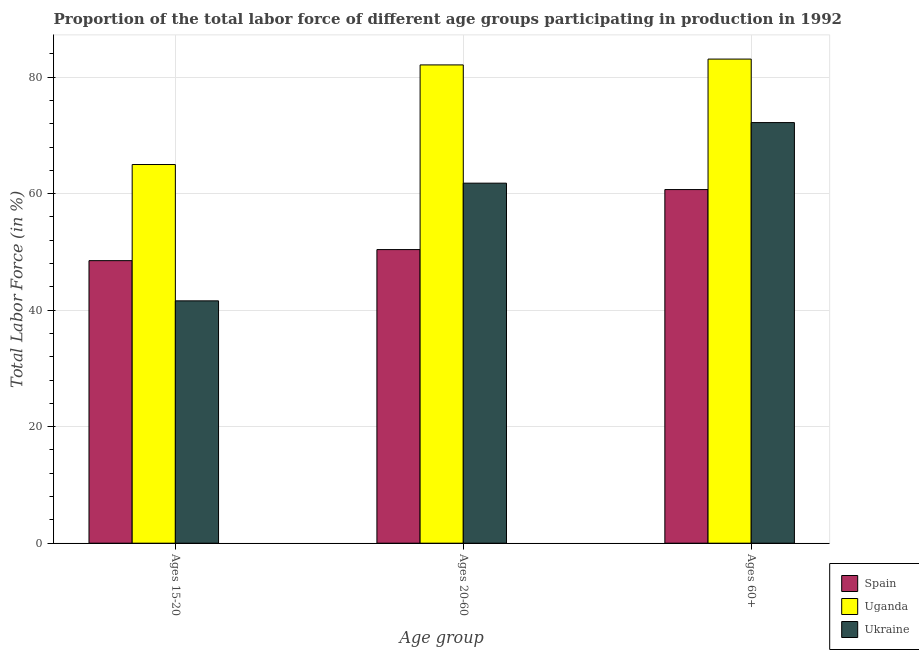How many groups of bars are there?
Keep it short and to the point. 3. Are the number of bars per tick equal to the number of legend labels?
Your response must be concise. Yes. How many bars are there on the 2nd tick from the left?
Provide a short and direct response. 3. What is the label of the 1st group of bars from the left?
Keep it short and to the point. Ages 15-20. What is the percentage of labor force above age 60 in Spain?
Keep it short and to the point. 60.7. Across all countries, what is the maximum percentage of labor force above age 60?
Your answer should be very brief. 83.1. Across all countries, what is the minimum percentage of labor force within the age group 20-60?
Make the answer very short. 50.4. In which country was the percentage of labor force within the age group 20-60 maximum?
Ensure brevity in your answer.  Uganda. In which country was the percentage of labor force within the age group 15-20 minimum?
Make the answer very short. Ukraine. What is the total percentage of labor force above age 60 in the graph?
Offer a terse response. 216. What is the difference between the percentage of labor force within the age group 20-60 in Ukraine and that in Uganda?
Keep it short and to the point. -20.3. What is the difference between the percentage of labor force within the age group 15-20 in Spain and the percentage of labor force within the age group 20-60 in Uganda?
Keep it short and to the point. -33.6. What is the average percentage of labor force within the age group 15-20 per country?
Offer a very short reply. 51.7. What is the difference between the percentage of labor force above age 60 and percentage of labor force within the age group 15-20 in Ukraine?
Ensure brevity in your answer.  30.6. What is the ratio of the percentage of labor force within the age group 15-20 in Spain to that in Uganda?
Offer a terse response. 0.75. Is the difference between the percentage of labor force above age 60 in Ukraine and Spain greater than the difference between the percentage of labor force within the age group 15-20 in Ukraine and Spain?
Offer a very short reply. Yes. What is the difference between the highest and the second highest percentage of labor force within the age group 20-60?
Make the answer very short. 20.3. What is the difference between the highest and the lowest percentage of labor force within the age group 15-20?
Offer a very short reply. 23.4. In how many countries, is the percentage of labor force above age 60 greater than the average percentage of labor force above age 60 taken over all countries?
Ensure brevity in your answer.  2. What does the 2nd bar from the left in Ages 15-20 represents?
Offer a very short reply. Uganda. Are all the bars in the graph horizontal?
Your answer should be compact. No. How many countries are there in the graph?
Your answer should be compact. 3. Does the graph contain any zero values?
Ensure brevity in your answer.  No. Does the graph contain grids?
Make the answer very short. Yes. What is the title of the graph?
Ensure brevity in your answer.  Proportion of the total labor force of different age groups participating in production in 1992. Does "Bhutan" appear as one of the legend labels in the graph?
Offer a terse response. No. What is the label or title of the X-axis?
Your response must be concise. Age group. What is the Total Labor Force (in %) of Spain in Ages 15-20?
Offer a terse response. 48.5. What is the Total Labor Force (in %) in Ukraine in Ages 15-20?
Your response must be concise. 41.6. What is the Total Labor Force (in %) in Spain in Ages 20-60?
Offer a terse response. 50.4. What is the Total Labor Force (in %) of Uganda in Ages 20-60?
Your answer should be compact. 82.1. What is the Total Labor Force (in %) in Ukraine in Ages 20-60?
Make the answer very short. 61.8. What is the Total Labor Force (in %) of Spain in Ages 60+?
Provide a short and direct response. 60.7. What is the Total Labor Force (in %) of Uganda in Ages 60+?
Provide a succinct answer. 83.1. What is the Total Labor Force (in %) in Ukraine in Ages 60+?
Provide a succinct answer. 72.2. Across all Age group, what is the maximum Total Labor Force (in %) in Spain?
Make the answer very short. 60.7. Across all Age group, what is the maximum Total Labor Force (in %) in Uganda?
Ensure brevity in your answer.  83.1. Across all Age group, what is the maximum Total Labor Force (in %) in Ukraine?
Your answer should be compact. 72.2. Across all Age group, what is the minimum Total Labor Force (in %) of Spain?
Ensure brevity in your answer.  48.5. Across all Age group, what is the minimum Total Labor Force (in %) in Uganda?
Ensure brevity in your answer.  65. Across all Age group, what is the minimum Total Labor Force (in %) of Ukraine?
Give a very brief answer. 41.6. What is the total Total Labor Force (in %) in Spain in the graph?
Your answer should be very brief. 159.6. What is the total Total Labor Force (in %) in Uganda in the graph?
Your answer should be compact. 230.2. What is the total Total Labor Force (in %) of Ukraine in the graph?
Your answer should be compact. 175.6. What is the difference between the Total Labor Force (in %) in Uganda in Ages 15-20 and that in Ages 20-60?
Your answer should be compact. -17.1. What is the difference between the Total Labor Force (in %) in Ukraine in Ages 15-20 and that in Ages 20-60?
Your response must be concise. -20.2. What is the difference between the Total Labor Force (in %) of Uganda in Ages 15-20 and that in Ages 60+?
Your response must be concise. -18.1. What is the difference between the Total Labor Force (in %) of Ukraine in Ages 15-20 and that in Ages 60+?
Make the answer very short. -30.6. What is the difference between the Total Labor Force (in %) in Uganda in Ages 20-60 and that in Ages 60+?
Your response must be concise. -1. What is the difference between the Total Labor Force (in %) of Spain in Ages 15-20 and the Total Labor Force (in %) of Uganda in Ages 20-60?
Offer a very short reply. -33.6. What is the difference between the Total Labor Force (in %) of Spain in Ages 15-20 and the Total Labor Force (in %) of Uganda in Ages 60+?
Give a very brief answer. -34.6. What is the difference between the Total Labor Force (in %) of Spain in Ages 15-20 and the Total Labor Force (in %) of Ukraine in Ages 60+?
Keep it short and to the point. -23.7. What is the difference between the Total Labor Force (in %) of Uganda in Ages 15-20 and the Total Labor Force (in %) of Ukraine in Ages 60+?
Offer a terse response. -7.2. What is the difference between the Total Labor Force (in %) of Spain in Ages 20-60 and the Total Labor Force (in %) of Uganda in Ages 60+?
Offer a very short reply. -32.7. What is the difference between the Total Labor Force (in %) of Spain in Ages 20-60 and the Total Labor Force (in %) of Ukraine in Ages 60+?
Provide a succinct answer. -21.8. What is the average Total Labor Force (in %) of Spain per Age group?
Ensure brevity in your answer.  53.2. What is the average Total Labor Force (in %) in Uganda per Age group?
Offer a terse response. 76.73. What is the average Total Labor Force (in %) of Ukraine per Age group?
Your answer should be very brief. 58.53. What is the difference between the Total Labor Force (in %) in Spain and Total Labor Force (in %) in Uganda in Ages 15-20?
Your answer should be compact. -16.5. What is the difference between the Total Labor Force (in %) of Spain and Total Labor Force (in %) of Ukraine in Ages 15-20?
Provide a short and direct response. 6.9. What is the difference between the Total Labor Force (in %) of Uganda and Total Labor Force (in %) of Ukraine in Ages 15-20?
Your response must be concise. 23.4. What is the difference between the Total Labor Force (in %) in Spain and Total Labor Force (in %) in Uganda in Ages 20-60?
Your answer should be compact. -31.7. What is the difference between the Total Labor Force (in %) in Uganda and Total Labor Force (in %) in Ukraine in Ages 20-60?
Provide a succinct answer. 20.3. What is the difference between the Total Labor Force (in %) of Spain and Total Labor Force (in %) of Uganda in Ages 60+?
Give a very brief answer. -22.4. What is the difference between the Total Labor Force (in %) of Spain and Total Labor Force (in %) of Ukraine in Ages 60+?
Provide a short and direct response. -11.5. What is the difference between the Total Labor Force (in %) of Uganda and Total Labor Force (in %) of Ukraine in Ages 60+?
Provide a short and direct response. 10.9. What is the ratio of the Total Labor Force (in %) in Spain in Ages 15-20 to that in Ages 20-60?
Make the answer very short. 0.96. What is the ratio of the Total Labor Force (in %) in Uganda in Ages 15-20 to that in Ages 20-60?
Your response must be concise. 0.79. What is the ratio of the Total Labor Force (in %) of Ukraine in Ages 15-20 to that in Ages 20-60?
Your answer should be compact. 0.67. What is the ratio of the Total Labor Force (in %) in Spain in Ages 15-20 to that in Ages 60+?
Ensure brevity in your answer.  0.8. What is the ratio of the Total Labor Force (in %) in Uganda in Ages 15-20 to that in Ages 60+?
Make the answer very short. 0.78. What is the ratio of the Total Labor Force (in %) of Ukraine in Ages 15-20 to that in Ages 60+?
Make the answer very short. 0.58. What is the ratio of the Total Labor Force (in %) in Spain in Ages 20-60 to that in Ages 60+?
Provide a short and direct response. 0.83. What is the ratio of the Total Labor Force (in %) in Ukraine in Ages 20-60 to that in Ages 60+?
Ensure brevity in your answer.  0.86. What is the difference between the highest and the second highest Total Labor Force (in %) of Uganda?
Give a very brief answer. 1. What is the difference between the highest and the lowest Total Labor Force (in %) of Uganda?
Your answer should be very brief. 18.1. What is the difference between the highest and the lowest Total Labor Force (in %) of Ukraine?
Your answer should be compact. 30.6. 